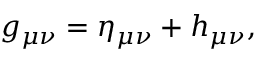<formula> <loc_0><loc_0><loc_500><loc_500>g _ { \mu \nu } = \eta _ { \mu \nu } + h _ { \mu \nu } ,</formula> 